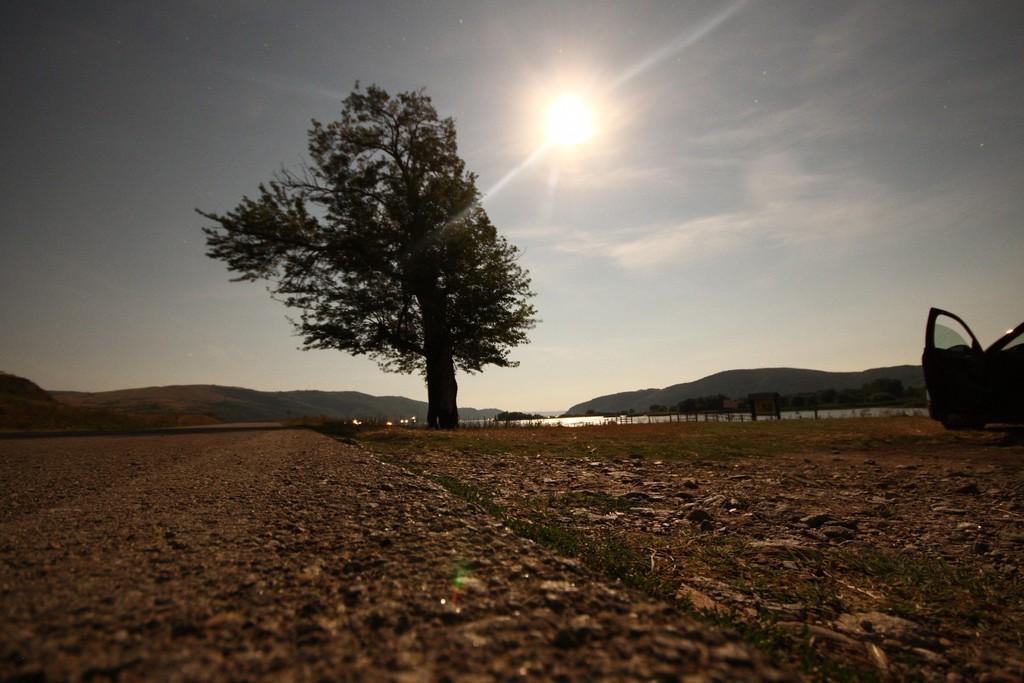In one or two sentences, can you explain what this image depicts? In this picture we can see a vehicle on the path and on the left side of the vehicle there is a tree and behind the tree there is water, hills and a sun in the sky. 